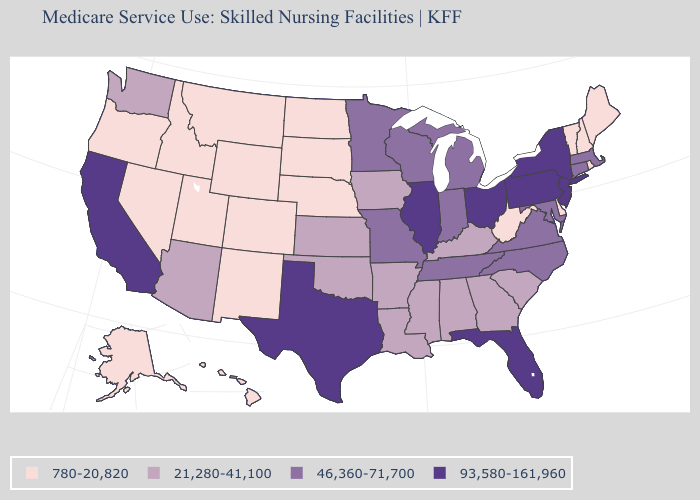Does Washington have the lowest value in the West?
Quick response, please. No. Name the states that have a value in the range 21,280-41,100?
Concise answer only. Alabama, Arizona, Arkansas, Georgia, Iowa, Kansas, Kentucky, Louisiana, Mississippi, Oklahoma, South Carolina, Washington. What is the value of North Carolina?
Answer briefly. 46,360-71,700. Which states have the highest value in the USA?
Quick response, please. California, Florida, Illinois, New Jersey, New York, Ohio, Pennsylvania, Texas. Which states have the lowest value in the South?
Quick response, please. Delaware, West Virginia. What is the lowest value in states that border Vermont?
Answer briefly. 780-20,820. Name the states that have a value in the range 21,280-41,100?
Write a very short answer. Alabama, Arizona, Arkansas, Georgia, Iowa, Kansas, Kentucky, Louisiana, Mississippi, Oklahoma, South Carolina, Washington. Does Texas have the highest value in the USA?
Quick response, please. Yes. Among the states that border Wisconsin , which have the highest value?
Keep it brief. Illinois. Which states hav the highest value in the MidWest?
Concise answer only. Illinois, Ohio. Name the states that have a value in the range 46,360-71,700?
Concise answer only. Connecticut, Indiana, Maryland, Massachusetts, Michigan, Minnesota, Missouri, North Carolina, Tennessee, Virginia, Wisconsin. Name the states that have a value in the range 780-20,820?
Keep it brief. Alaska, Colorado, Delaware, Hawaii, Idaho, Maine, Montana, Nebraska, Nevada, New Hampshire, New Mexico, North Dakota, Oregon, Rhode Island, South Dakota, Utah, Vermont, West Virginia, Wyoming. What is the value of Alabama?
Keep it brief. 21,280-41,100. Which states have the highest value in the USA?
Keep it brief. California, Florida, Illinois, New Jersey, New York, Ohio, Pennsylvania, Texas. What is the highest value in the MidWest ?
Quick response, please. 93,580-161,960. 